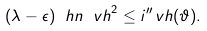Convert formula to latex. <formula><loc_0><loc_0><loc_500><loc_500>( \lambda - \epsilon ) \ h n { \ v h } ^ { 2 } \leq i ^ { \prime \prime } _ { \ } v h ( \vartheta ) .</formula> 